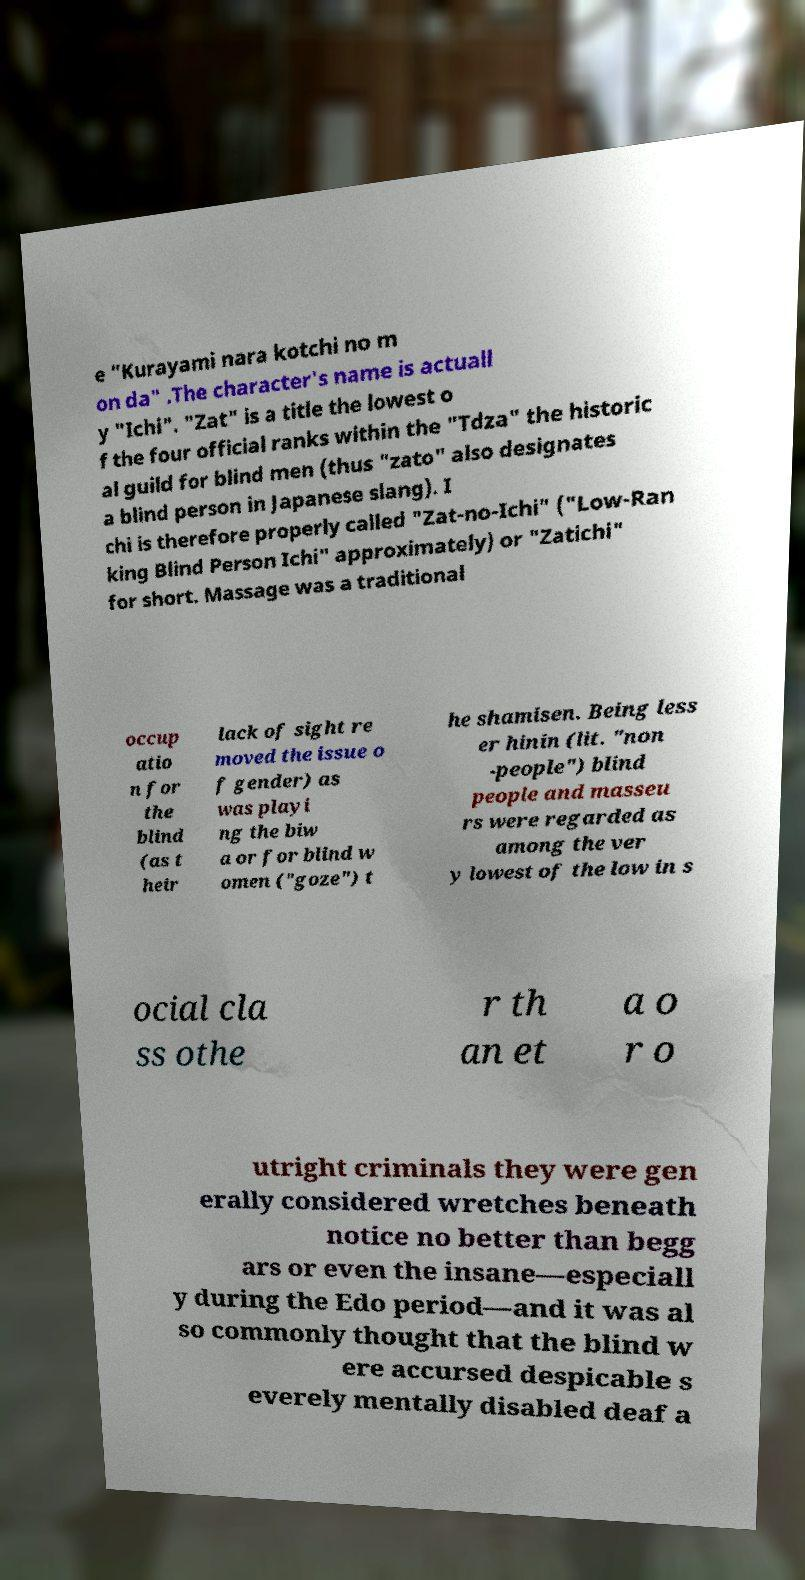Could you assist in decoding the text presented in this image and type it out clearly? e "Kurayami nara kotchi no m on da" .The character's name is actuall y "Ichi". "Zat" is a title the lowest o f the four official ranks within the "Tdza" the historic al guild for blind men (thus "zato" also designates a blind person in Japanese slang). I chi is therefore properly called "Zat-no-Ichi" ("Low-Ran king Blind Person Ichi" approximately) or "Zatichi" for short. Massage was a traditional occup atio n for the blind (as t heir lack of sight re moved the issue o f gender) as was playi ng the biw a or for blind w omen ("goze") t he shamisen. Being less er hinin (lit. "non -people") blind people and masseu rs were regarded as among the ver y lowest of the low in s ocial cla ss othe r th an et a o r o utright criminals they were gen erally considered wretches beneath notice no better than begg ars or even the insane—especiall y during the Edo period—and it was al so commonly thought that the blind w ere accursed despicable s everely mentally disabled deaf a 